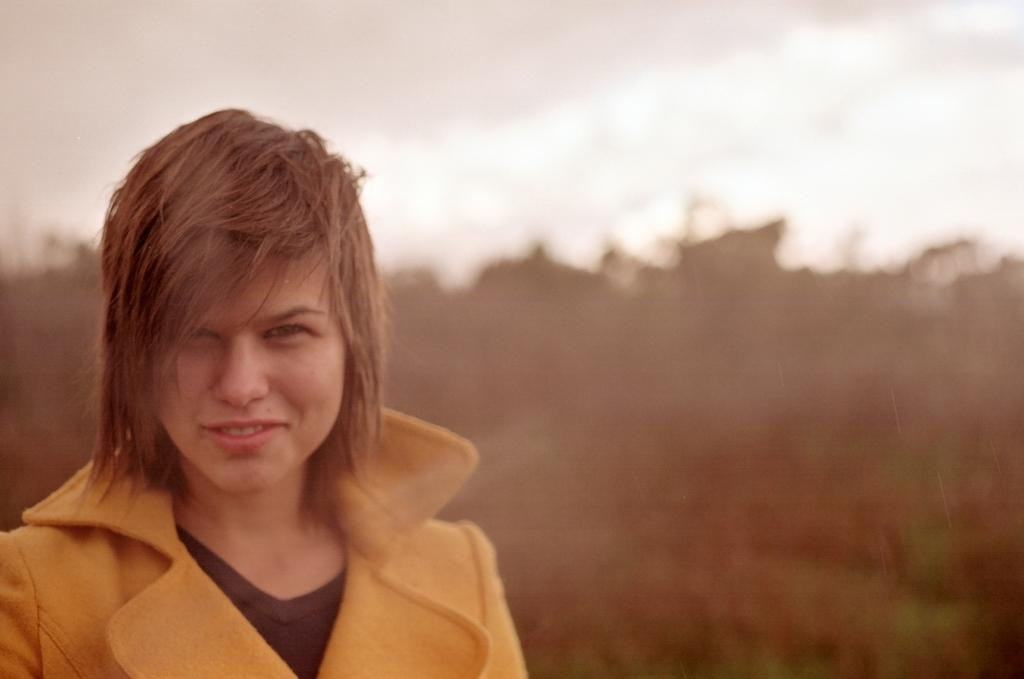Who is present in the image? There are women in the image. What can be seen in the background of the image? There are trees and the sky visible in the background of the image. What type of wine is being served at the school in the image? There is no school or wine present in the image; it features women and a background with trees and the sky. 